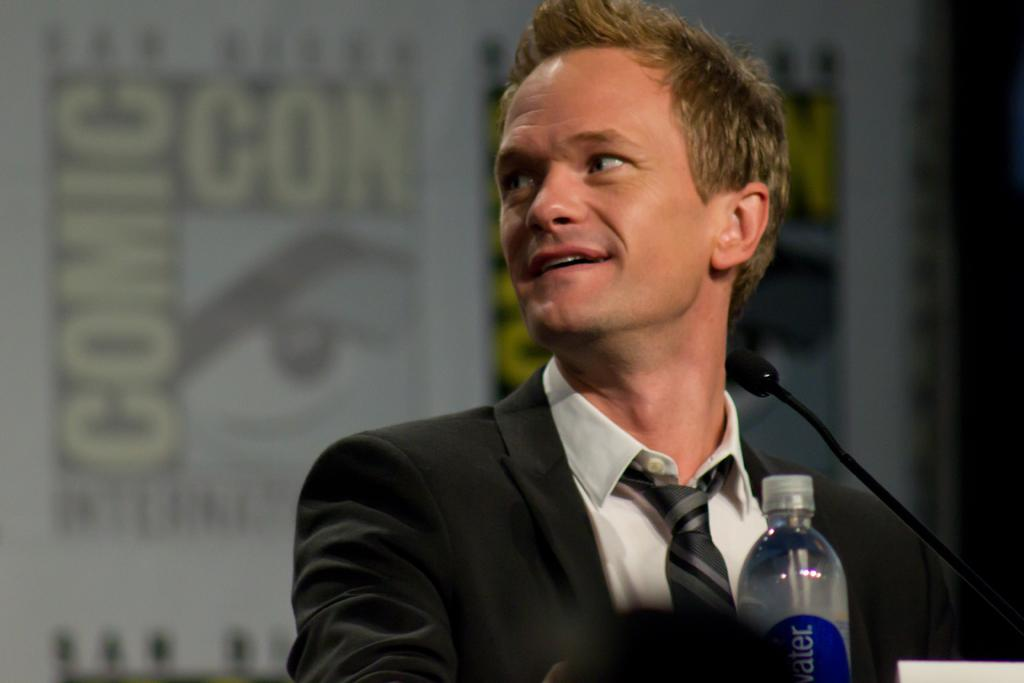Who is present in the image? There is a man in the image. What is the man doing in the image? The man is standing and smiling. What object is in front of the man? There is a microphone in front of the man. Is there any other object visible in the image? Yes, there is a water bottle in the image. What type of wool is being used to make the man's shirt in the image? There is no information about the man's shirt or the type of wool used in the image. 